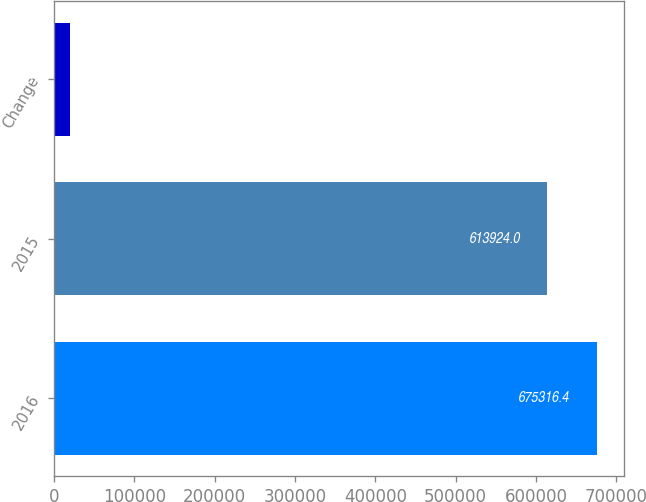Convert chart to OTSL. <chart><loc_0><loc_0><loc_500><loc_500><bar_chart><fcel>2016<fcel>2015<fcel>Change<nl><fcel>675316<fcel>613924<fcel>20196<nl></chart> 